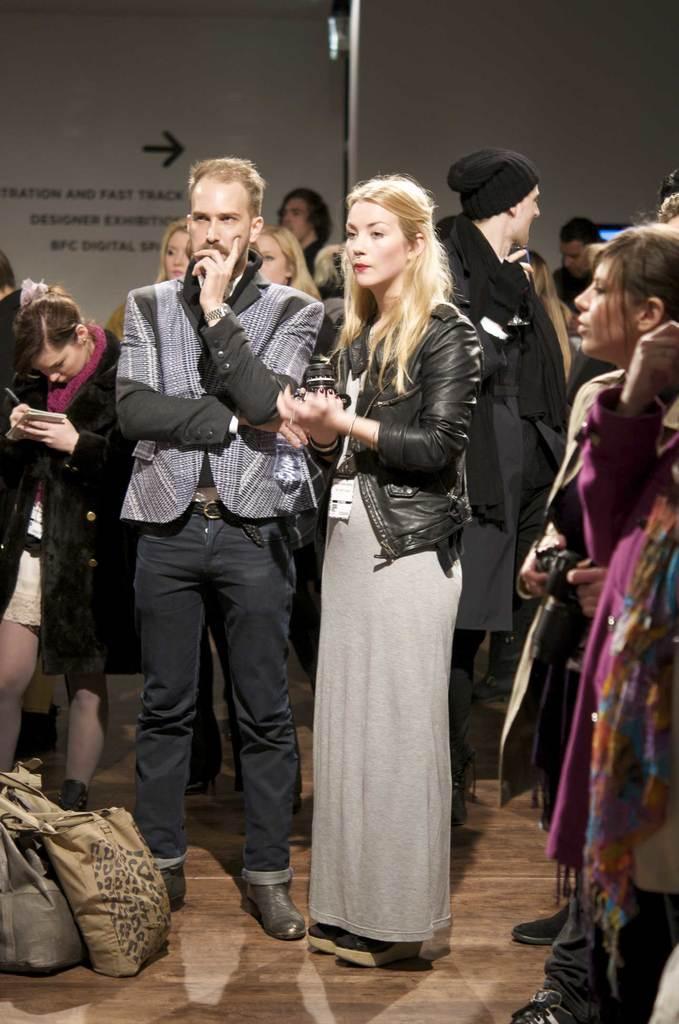How would you summarize this image in a sentence or two? In this picture we can see few people are standing on the floor and there are bags. In the background we can see hoardings. 